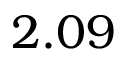Convert formula to latex. <formula><loc_0><loc_0><loc_500><loc_500>2 . 0 9</formula> 